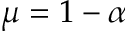<formula> <loc_0><loc_0><loc_500><loc_500>\mu = 1 - \alpha</formula> 